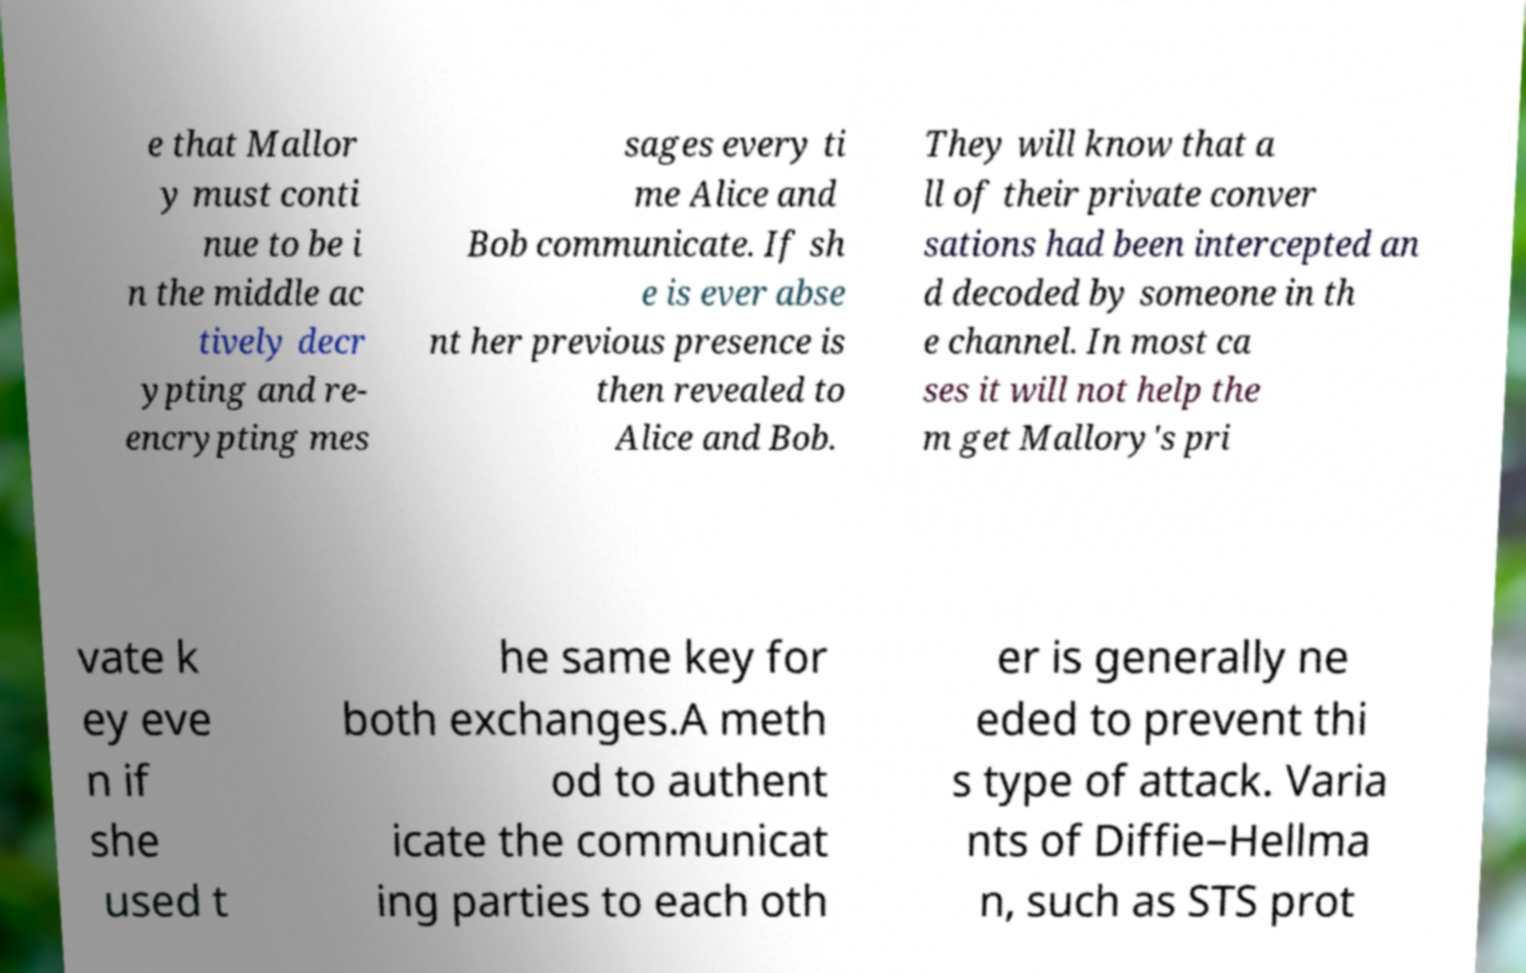I need the written content from this picture converted into text. Can you do that? e that Mallor y must conti nue to be i n the middle ac tively decr ypting and re- encrypting mes sages every ti me Alice and Bob communicate. If sh e is ever abse nt her previous presence is then revealed to Alice and Bob. They will know that a ll of their private conver sations had been intercepted an d decoded by someone in th e channel. In most ca ses it will not help the m get Mallory's pri vate k ey eve n if she used t he same key for both exchanges.A meth od to authent icate the communicat ing parties to each oth er is generally ne eded to prevent thi s type of attack. Varia nts of Diffie–Hellma n, such as STS prot 